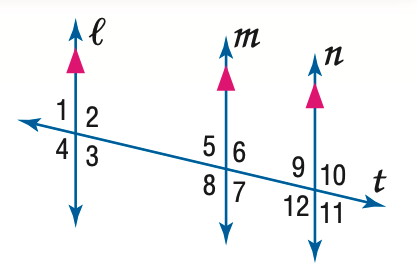Answer the mathemtical geometry problem and directly provide the correct option letter.
Question: In the figure, m \angle 9 = 75. Find the measure of \angle 12.
Choices: A: 75 B: 85 C: 95 D: 105 D 